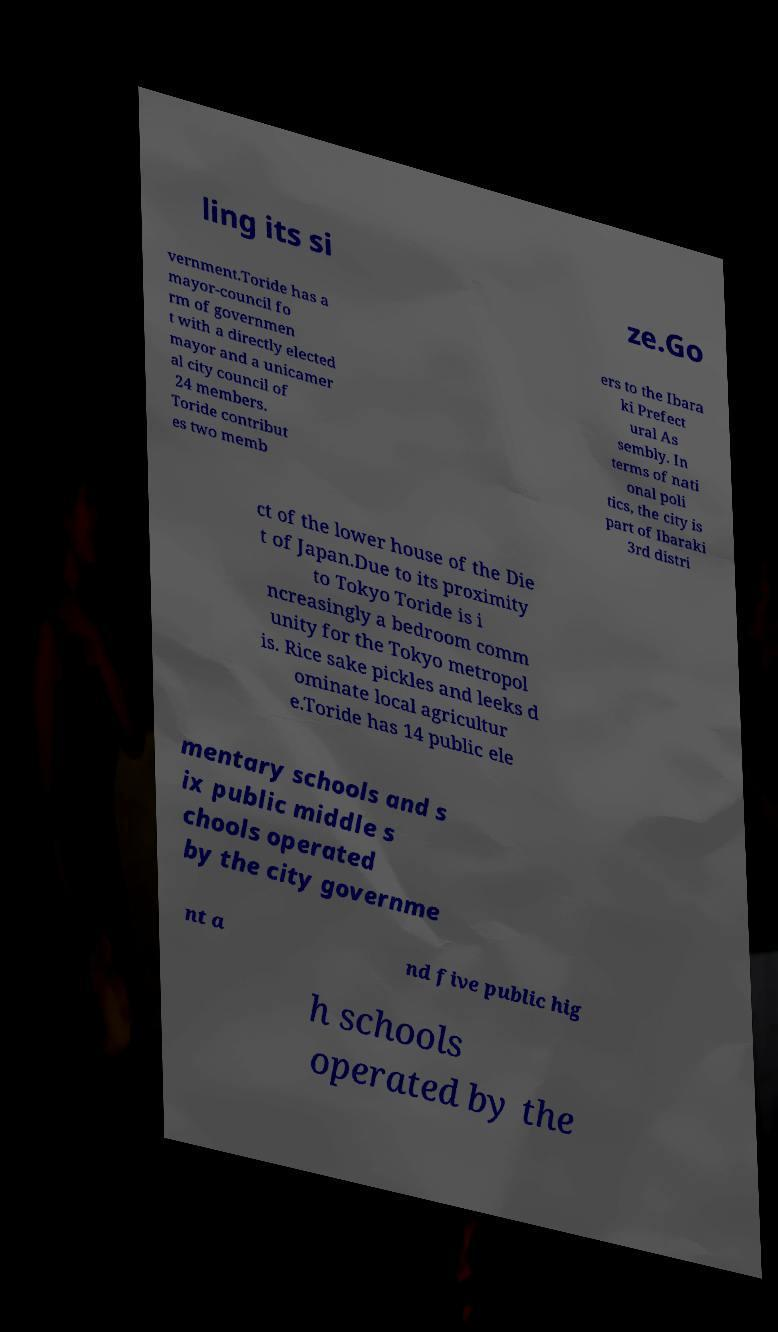Can you accurately transcribe the text from the provided image for me? ling its si ze.Go vernment.Toride has a mayor-council fo rm of governmen t with a directly elected mayor and a unicamer al city council of 24 members. Toride contribut es two memb ers to the Ibara ki Prefect ural As sembly. In terms of nati onal poli tics, the city is part of Ibaraki 3rd distri ct of the lower house of the Die t of Japan.Due to its proximity to Tokyo Toride is i ncreasingly a bedroom comm unity for the Tokyo metropol is. Rice sake pickles and leeks d ominate local agricultur e.Toride has 14 public ele mentary schools and s ix public middle s chools operated by the city governme nt a nd five public hig h schools operated by the 